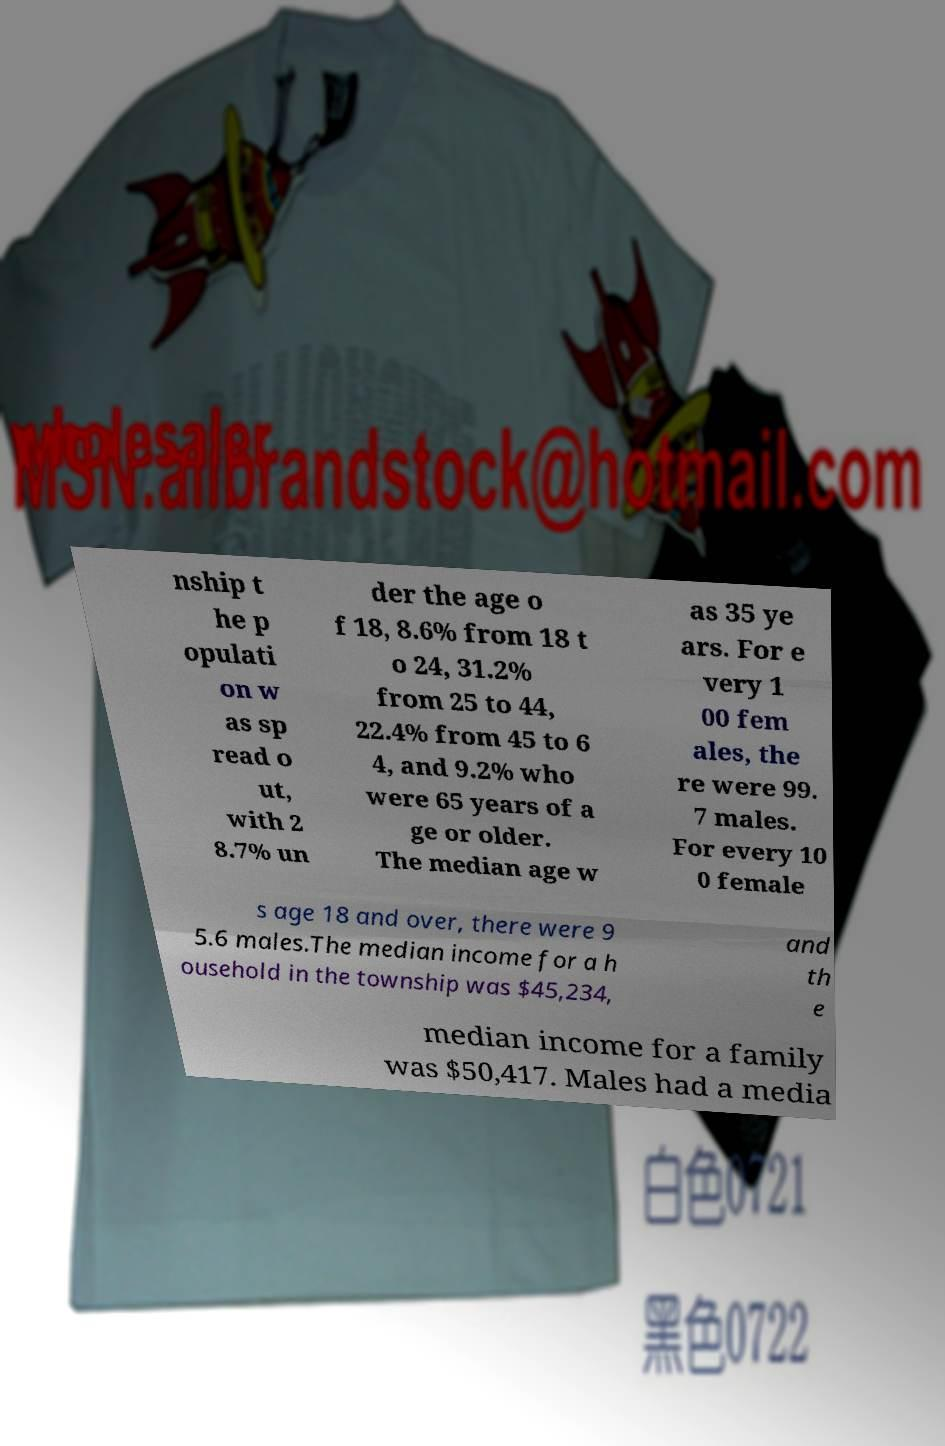Please read and relay the text visible in this image. What does it say? nship t he p opulati on w as sp read o ut, with 2 8.7% un der the age o f 18, 8.6% from 18 t o 24, 31.2% from 25 to 44, 22.4% from 45 to 6 4, and 9.2% who were 65 years of a ge or older. The median age w as 35 ye ars. For e very 1 00 fem ales, the re were 99. 7 males. For every 10 0 female s age 18 and over, there were 9 5.6 males.The median income for a h ousehold in the township was $45,234, and th e median income for a family was $50,417. Males had a media 